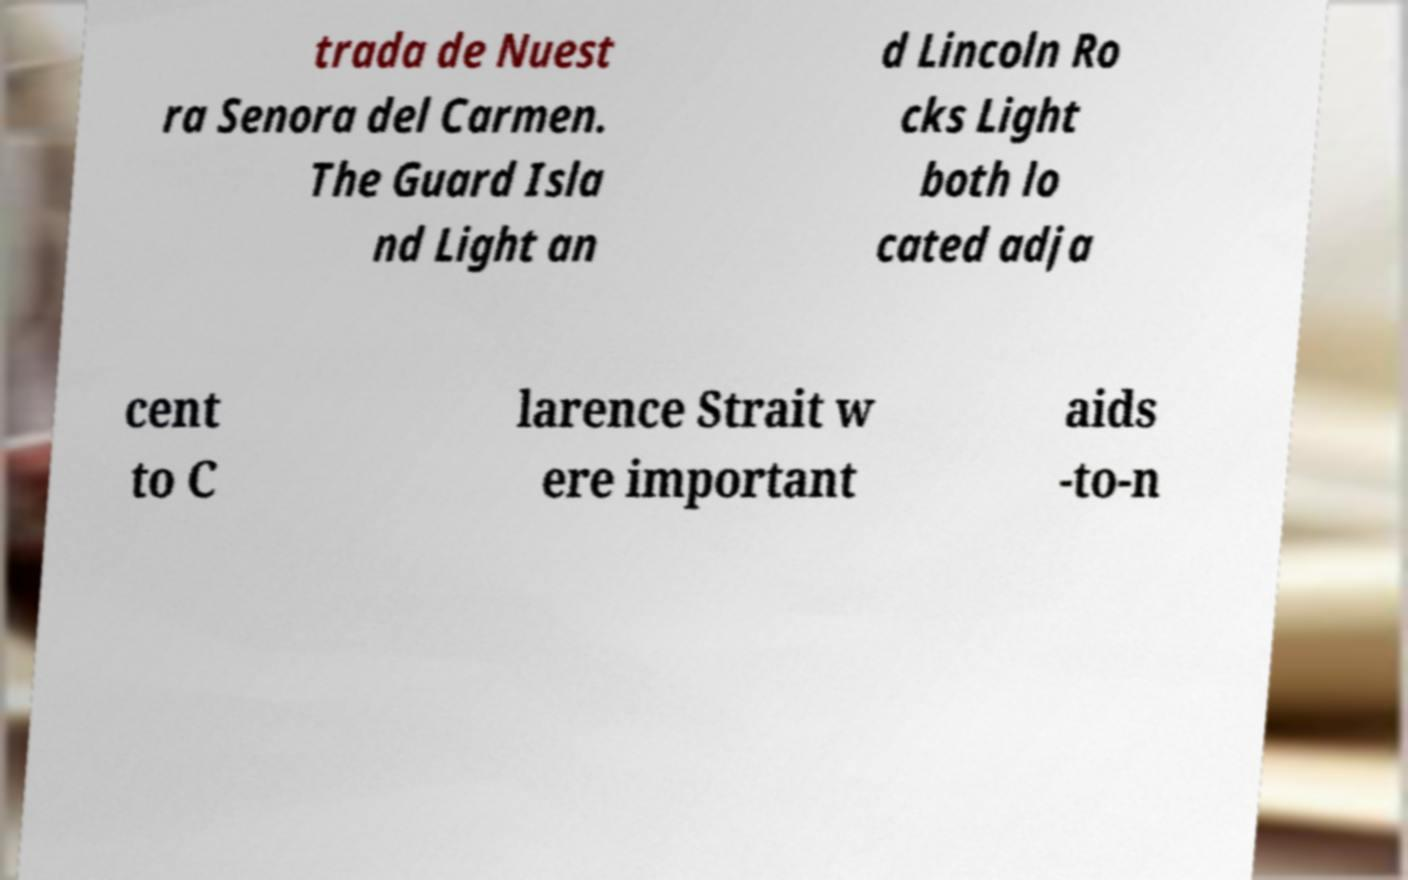There's text embedded in this image that I need extracted. Can you transcribe it verbatim? trada de Nuest ra Senora del Carmen. The Guard Isla nd Light an d Lincoln Ro cks Light both lo cated adja cent to C larence Strait w ere important aids -to-n 